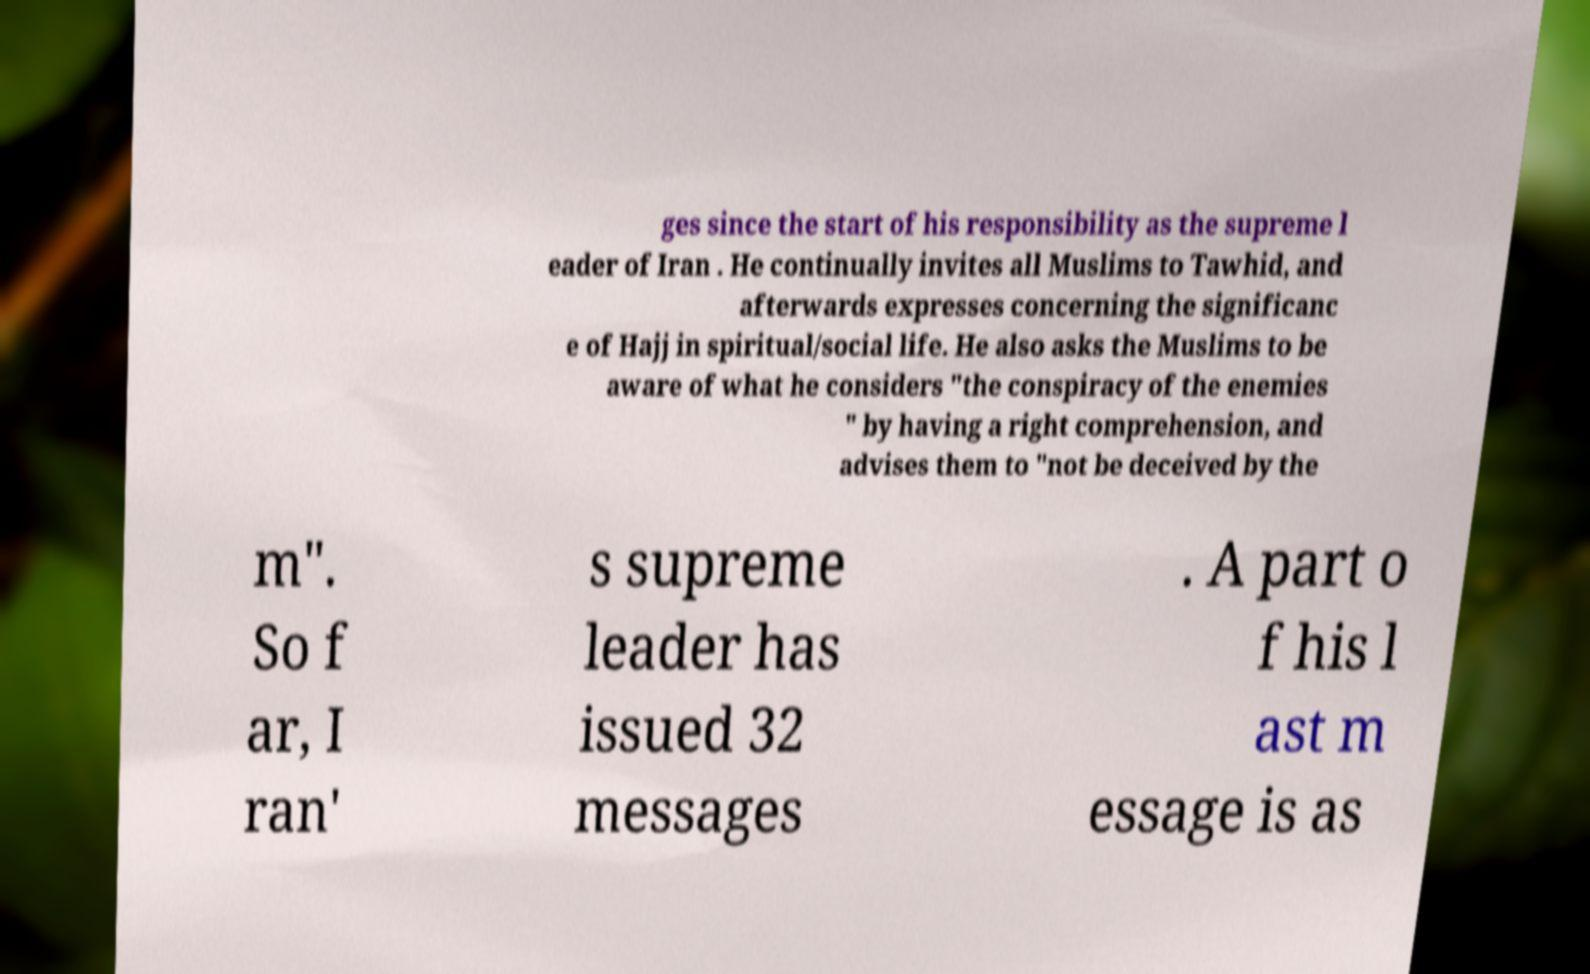For documentation purposes, I need the text within this image transcribed. Could you provide that? ges since the start of his responsibility as the supreme l eader of Iran . He continually invites all Muslims to Tawhid, and afterwards expresses concerning the significanc e of Hajj in spiritual/social life. He also asks the Muslims to be aware of what he considers "the conspiracy of the enemies " by having a right comprehension, and advises them to "not be deceived by the m". So f ar, I ran' s supreme leader has issued 32 messages . A part o f his l ast m essage is as 